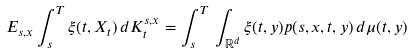Convert formula to latex. <formula><loc_0><loc_0><loc_500><loc_500>E _ { s , x } \int _ { s } ^ { T } \xi ( t , X _ { t } ) \, d K ^ { s , x } _ { t } = \int _ { s } ^ { T } \, \int _ { \mathbb { R } ^ { d } } \xi ( t , y ) p ( s , x , t , y ) \, d \mu ( t , y )</formula> 